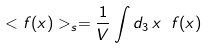<formula> <loc_0><loc_0><loc_500><loc_500>< f ( x ) > _ { s } = { \frac { 1 } { V } } \int d _ { 3 } \, x \ f ( x )</formula> 